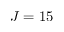<formula> <loc_0><loc_0><loc_500><loc_500>J = 1 5</formula> 